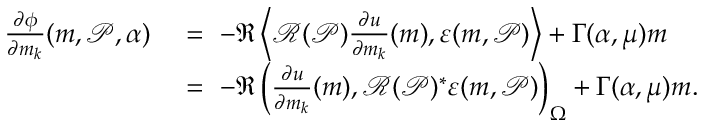<formula> <loc_0><loc_0><loc_500><loc_500>\begin{array} { r l } { \frac { \partial \phi } { \partial m _ { k } } ( m , \mathcal { P } , \alpha ) \ } & { = \ - \Re \left \langle \mathcal { R } ( \mathcal { P } ) \frac { \partial u } { \partial m _ { k } } ( m ) , \varepsilon ( m , \mathcal { P } ) \right \rangle + \Gamma ( \alpha , \mu ) m } \\ { \ } & { = \ - \Re \left ( \frac { \partial u } { \partial m _ { k } } ( m ) , \mathcal { R } ( \mathcal { P } ) ^ { * } \varepsilon ( m , \mathcal { P } ) \right ) _ { \Omega } + \Gamma ( \alpha , \mu ) m . } \end{array}</formula> 